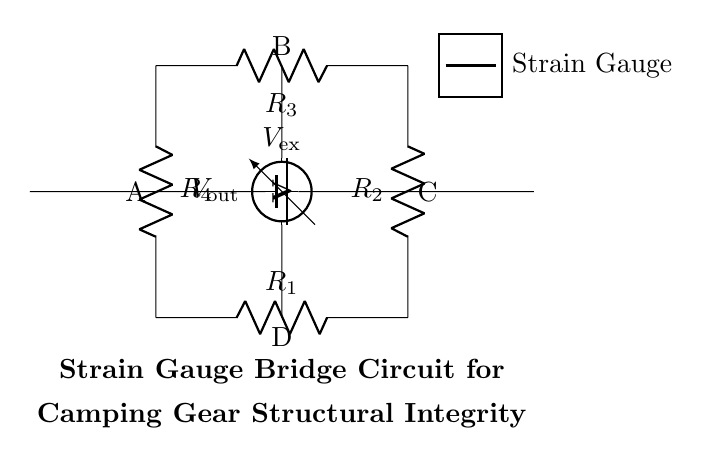What is the configuration of the circuit? The circuit is a Wheatstone bridge configuration, where four resistors are arranged in a diamond shape.
Answer: Wheatstone bridge How many resistors are present in the circuit? There are four resistors labeled R1, R2, R3, and R4 within the bridge circuit.
Answer: Four What is the purpose of the voltage source in the circuit? The voltage source provides the excitation voltage necessary for the bridge to operate and allows for the measurement of any voltage changes due to strain.
Answer: Excitation What does the voltmeter measure? The voltmeter measures the output voltage across points B and D which indicates the balance of the bridge circuit and any strain effects.
Answer: Output voltage What occurs if one of the strain gauges experiences deformation? If one strain gauge deforms, it will create an imbalance in the bridge, resulting in a change in the voltage measured by the voltmeter.
Answer: Imbalance How can this circuit be useful for camping gear? This circuit monitors the structural integrity of camping gear by detecting strain changes, which can be caused by loads or stresses on the gear.
Answer: Structural integrity What are the points labeled in the circuit diagram? The points are labeled A, B, C, and D, which correspond to the connections across the resistors and the voltmeter in the bridge configuration.
Answer: A, B, C, D 